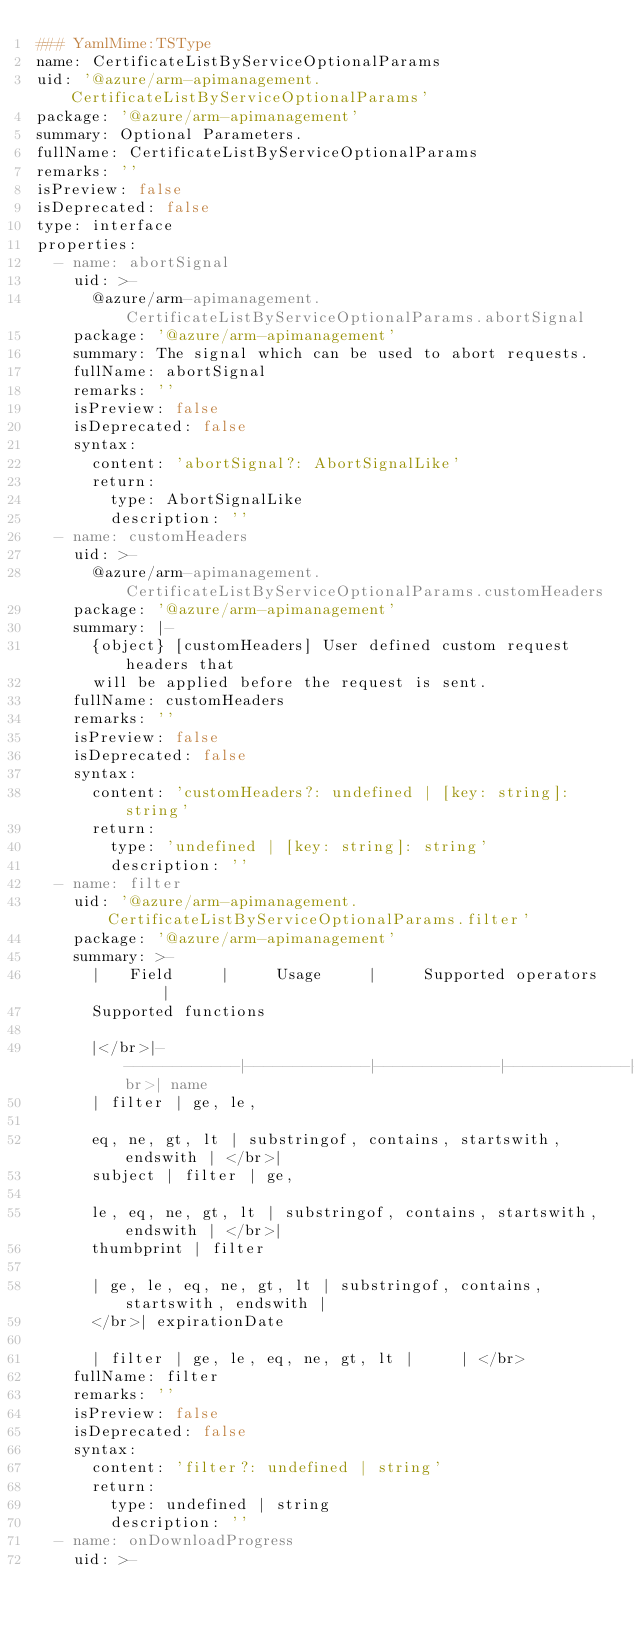Convert code to text. <code><loc_0><loc_0><loc_500><loc_500><_YAML_>### YamlMime:TSType
name: CertificateListByServiceOptionalParams
uid: '@azure/arm-apimanagement.CertificateListByServiceOptionalParams'
package: '@azure/arm-apimanagement'
summary: Optional Parameters.
fullName: CertificateListByServiceOptionalParams
remarks: ''
isPreview: false
isDeprecated: false
type: interface
properties:
  - name: abortSignal
    uid: >-
      @azure/arm-apimanagement.CertificateListByServiceOptionalParams.abortSignal
    package: '@azure/arm-apimanagement'
    summary: The signal which can be used to abort requests.
    fullName: abortSignal
    remarks: ''
    isPreview: false
    isDeprecated: false
    syntax:
      content: 'abortSignal?: AbortSignalLike'
      return:
        type: AbortSignalLike
        description: ''
  - name: customHeaders
    uid: >-
      @azure/arm-apimanagement.CertificateListByServiceOptionalParams.customHeaders
    package: '@azure/arm-apimanagement'
    summary: |-
      {object} [customHeaders] User defined custom request headers that
      will be applied before the request is sent.
    fullName: customHeaders
    remarks: ''
    isPreview: false
    isDeprecated: false
    syntax:
      content: 'customHeaders?: undefined | [key: string]: string'
      return:
        type: 'undefined | [key: string]: string'
        description: ''
  - name: filter
    uid: '@azure/arm-apimanagement.CertificateListByServiceOptionalParams.filter'
    package: '@azure/arm-apimanagement'
    summary: >-
      |   Field     |     Usage     |     Supported operators     |    
      Supported functions

      |</br>|-------------|-------------|-------------|-------------|</br>| name
      | filter | ge, le,

      eq, ne, gt, lt | substringof, contains, startswith, endswith | </br>|
      subject | filter | ge,

      le, eq, ne, gt, lt | substringof, contains, startswith, endswith | </br>|
      thumbprint | filter

      | ge, le, eq, ne, gt, lt | substringof, contains, startswith, endswith |
      </br>| expirationDate

      | filter | ge, le, eq, ne, gt, lt |     | </br>
    fullName: filter
    remarks: ''
    isPreview: false
    isDeprecated: false
    syntax:
      content: 'filter?: undefined | string'
      return:
        type: undefined | string
        description: ''
  - name: onDownloadProgress
    uid: >-</code> 